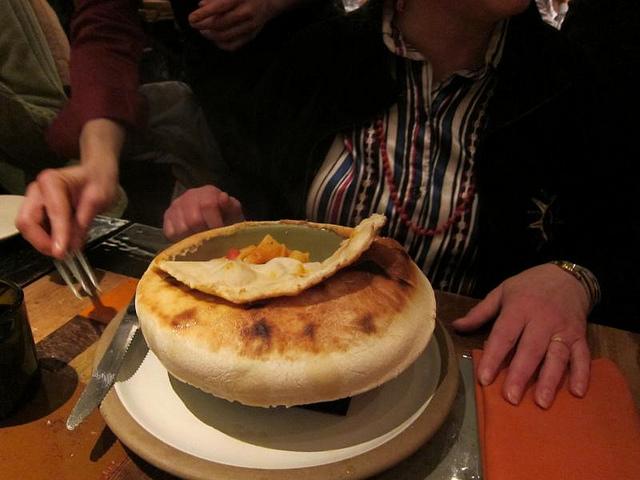Is this pot pie half eaten?
Be succinct. Yes. What are they eating?
Concise answer only. Pot pie. What is the pattern on the woman's shirt?
Quick response, please. Stripes. 